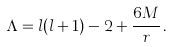<formula> <loc_0><loc_0><loc_500><loc_500>\Lambda & = l ( l + 1 ) - 2 + \frac { 6 M } { r } \, .</formula> 